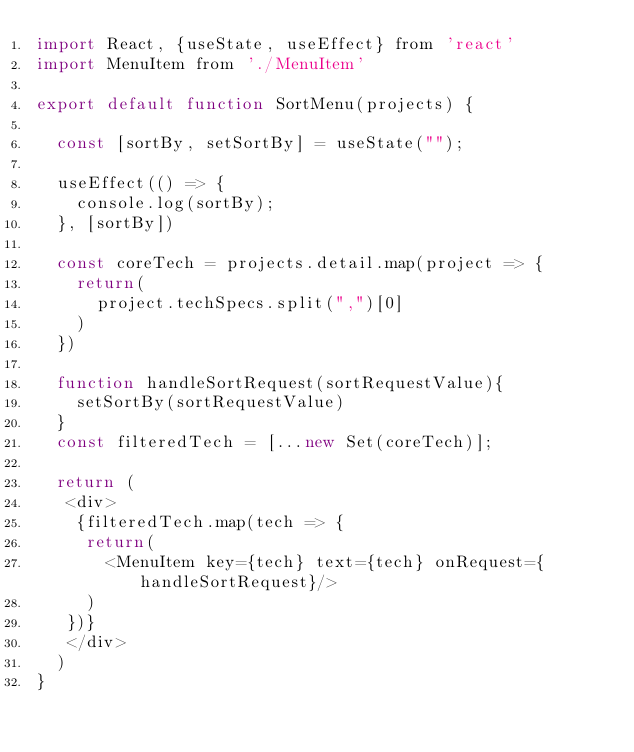Convert code to text. <code><loc_0><loc_0><loc_500><loc_500><_JavaScript_>import React, {useState, useEffect} from 'react'
import MenuItem from './MenuItem'

export default function SortMenu(projects) {

  const [sortBy, setSortBy] = useState("");

  useEffect(() => {
    console.log(sortBy);
  }, [sortBy])

  const coreTech = projects.detail.map(project => {
    return(
      project.techSpecs.split(",")[0]
    )
  })
  
  function handleSortRequest(sortRequestValue){
    setSortBy(sortRequestValue)
  }
  const filteredTech = [...new Set(coreTech)];

  return (
   <div>
    {filteredTech.map(tech => {
     return(
       <MenuItem key={tech} text={tech} onRequest={handleSortRequest}/>
     )
   })}
   </div>
  )
}
</code> 